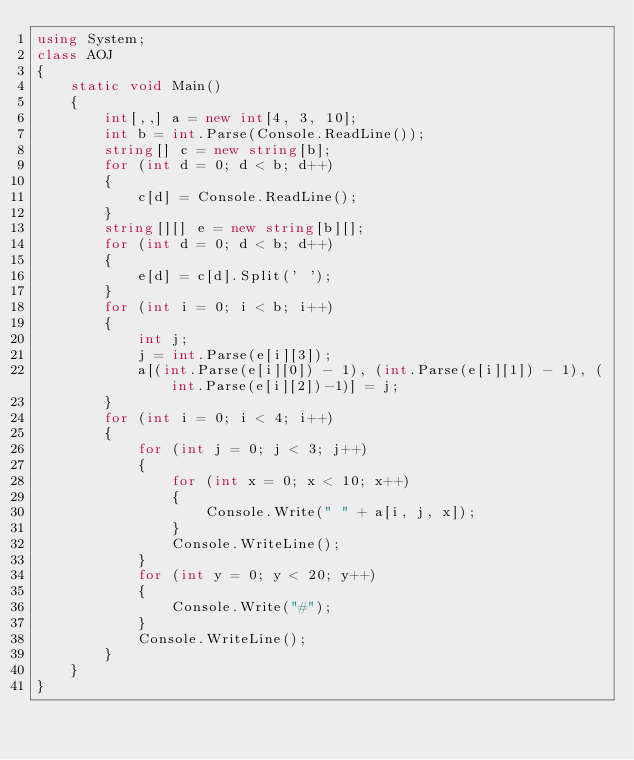Convert code to text. <code><loc_0><loc_0><loc_500><loc_500><_C#_>using System;
class AOJ
{
    static void Main()
    {
        int[,,] a = new int[4, 3, 10];
        int b = int.Parse(Console.ReadLine());
        string[] c = new string[b];
        for (int d = 0; d < b; d++)
        {
            c[d] = Console.ReadLine();
        }
        string[][] e = new string[b][];
        for (int d = 0; d < b; d++)
        {
            e[d] = c[d].Split(' ');
        }
        for (int i = 0; i < b; i++)
        {
            int j;
            j = int.Parse(e[i][3]);
            a[(int.Parse(e[i][0]) - 1), (int.Parse(e[i][1]) - 1), (int.Parse(e[i][2])-1)] = j;
        }
        for (int i = 0; i < 4; i++)
        {
            for (int j = 0; j < 3; j++)
            {
                for (int x = 0; x < 10; x++)
                {
                    Console.Write(" " + a[i, j, x]);
                }
                Console.WriteLine();
            }
            for (int y = 0; y < 20; y++)
            {
                Console.Write("#");
            }
            Console.WriteLine();
        }
    }
}</code> 